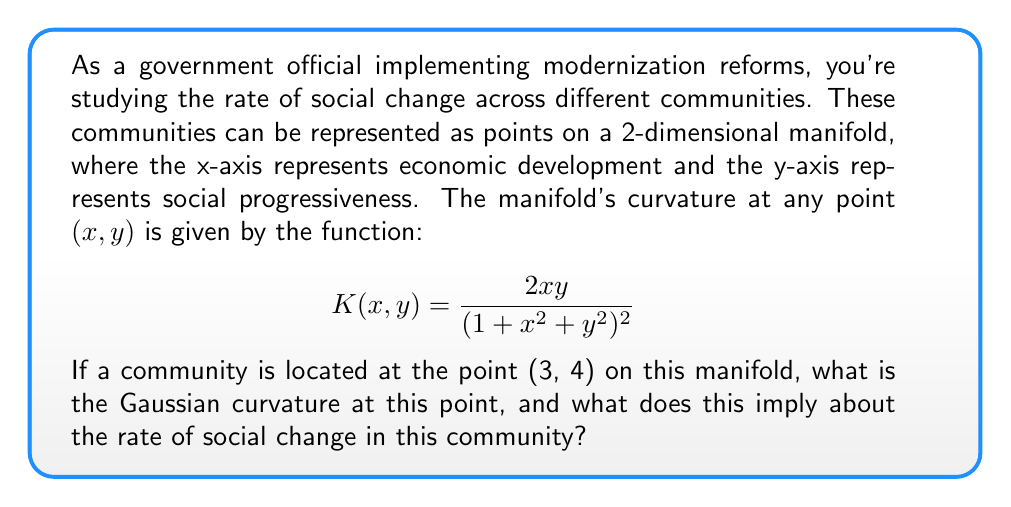What is the answer to this math problem? To solve this problem, we need to follow these steps:

1) We are given the Gaussian curvature function:

   $$K(x,y) = \frac{2xy}{(1+x^2+y^2)^2}$$

2) We need to evaluate this function at the point (3, 4). Let's substitute x = 3 and y = 4:

   $$K(3,4) = \frac{2(3)(4)}{(1+3^2+4^2)^2}$$

3) Simplify the numerator:
   
   $$K(3,4) = \frac{24}{(1+9+16)^2}$$

4) Simplify the denominator:

   $$K(3,4) = \frac{24}{(26)^2} = \frac{24}{676}$$

5) Simplify the fraction:

   $$K(3,4) = \frac{6}{169} \approx 0.0355$$

Interpretation:
The Gaussian curvature is positive but close to zero. In the context of social change:

- Positive curvature suggests that social change in this community is accelerating, but at a relatively slow rate.
- The low magnitude implies that the community is not experiencing rapid or dramatic changes.
- This could indicate a community that is gradually embracing modernization reforms, but still maintaining some traditional aspects.

As a government official, this suggests that while your reforms are having an effect, there might still be some resistance or slow adoption in this particular community. The change is happening, but at a measured pace.
Answer: The Gaussian curvature at the point (3, 4) is $\frac{6}{169} \approx 0.0355$. This positive but small value indicates that social change in this community is accelerating, but at a relatively slow rate, suggesting gradual acceptance of modernization reforms with some persistence of traditional elements. 